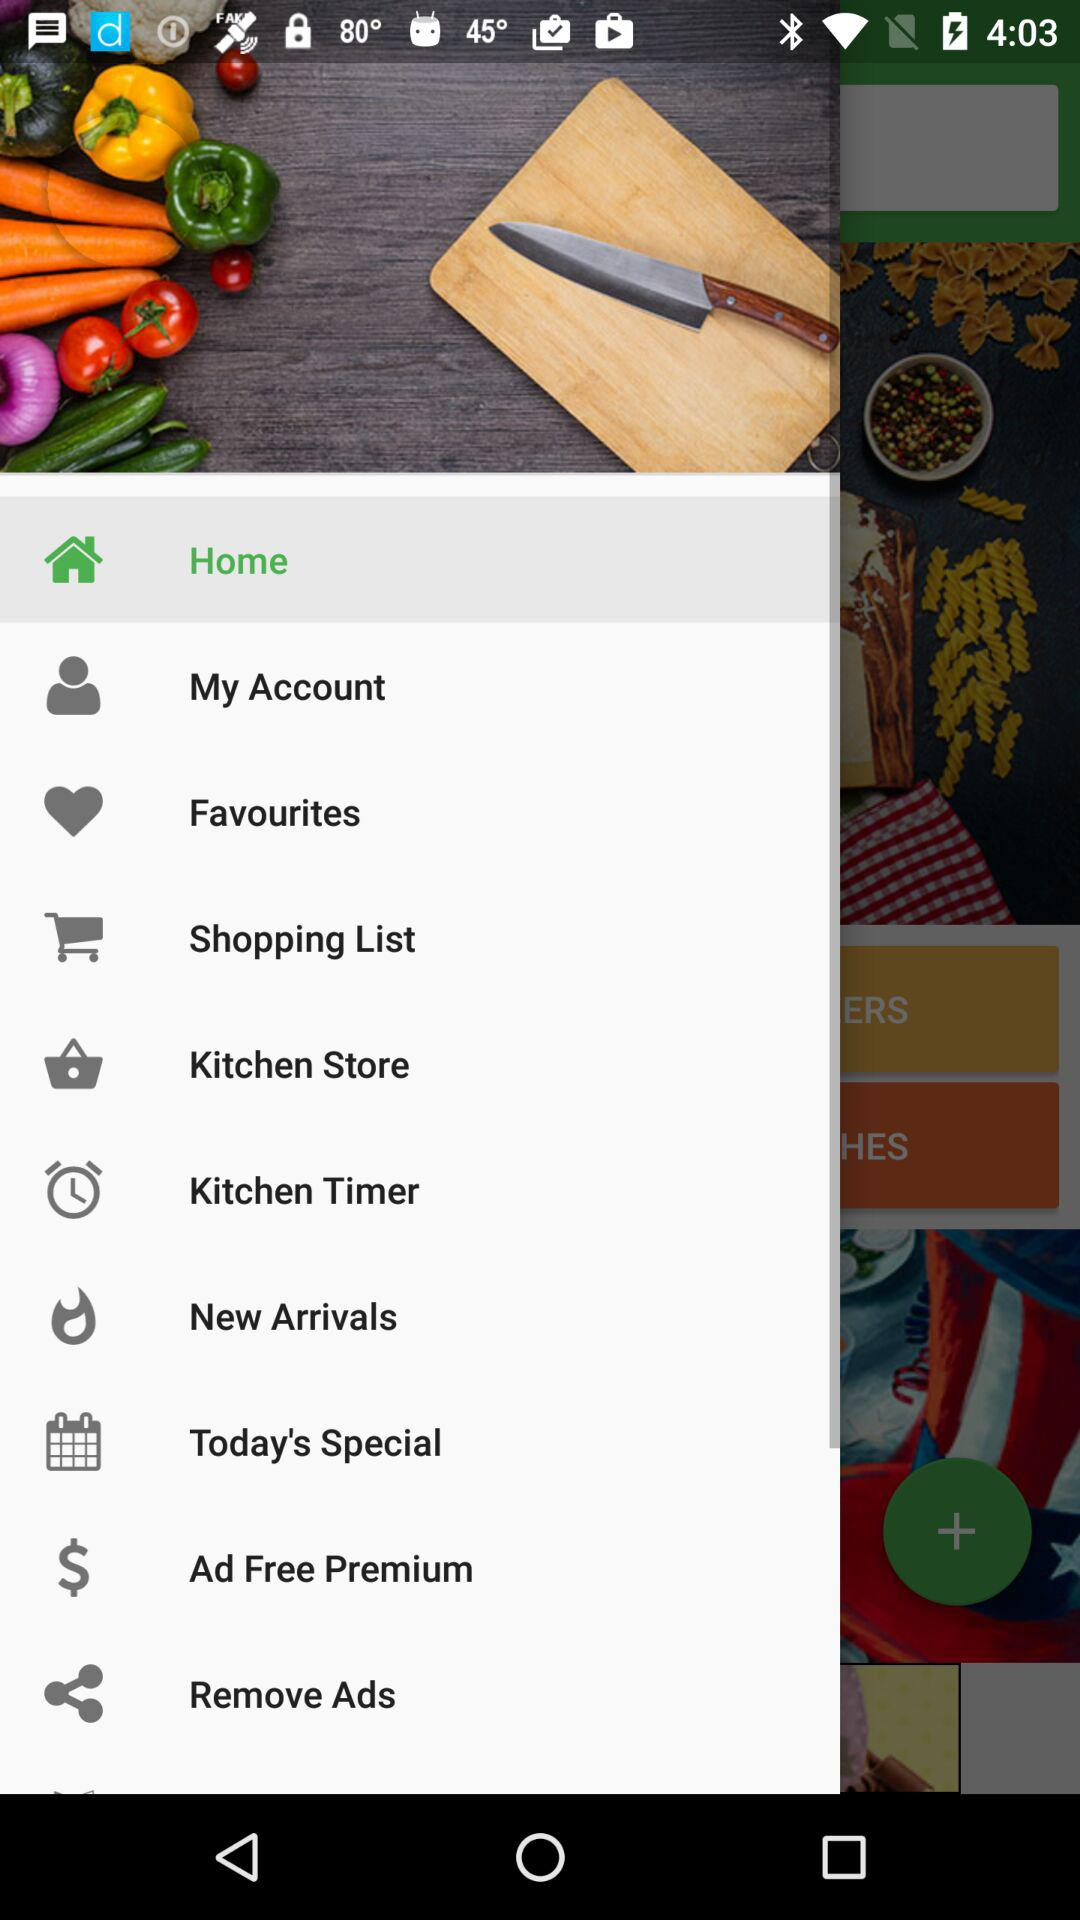Which item is selected? The selected item is "Home". 